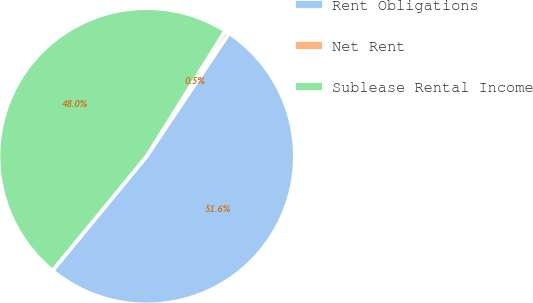Convert chart to OTSL. <chart><loc_0><loc_0><loc_500><loc_500><pie_chart><fcel>Rent Obligations<fcel>Net Rent<fcel>Sublease Rental Income<nl><fcel>51.56%<fcel>0.49%<fcel>47.95%<nl></chart> 